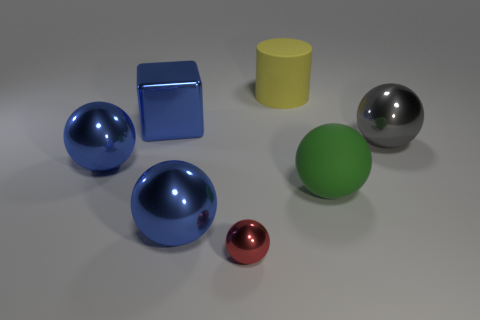Subtract all green spheres. How many spheres are left? 4 Subtract all big green rubber spheres. How many spheres are left? 4 Subtract all purple spheres. Subtract all cyan cylinders. How many spheres are left? 5 Add 2 large gray rubber balls. How many objects exist? 9 Subtract all spheres. How many objects are left? 2 Subtract 0 blue cylinders. How many objects are left? 7 Subtract all big brown matte things. Subtract all big yellow things. How many objects are left? 6 Add 5 green spheres. How many green spheres are left? 6 Add 7 red metallic things. How many red metallic things exist? 8 